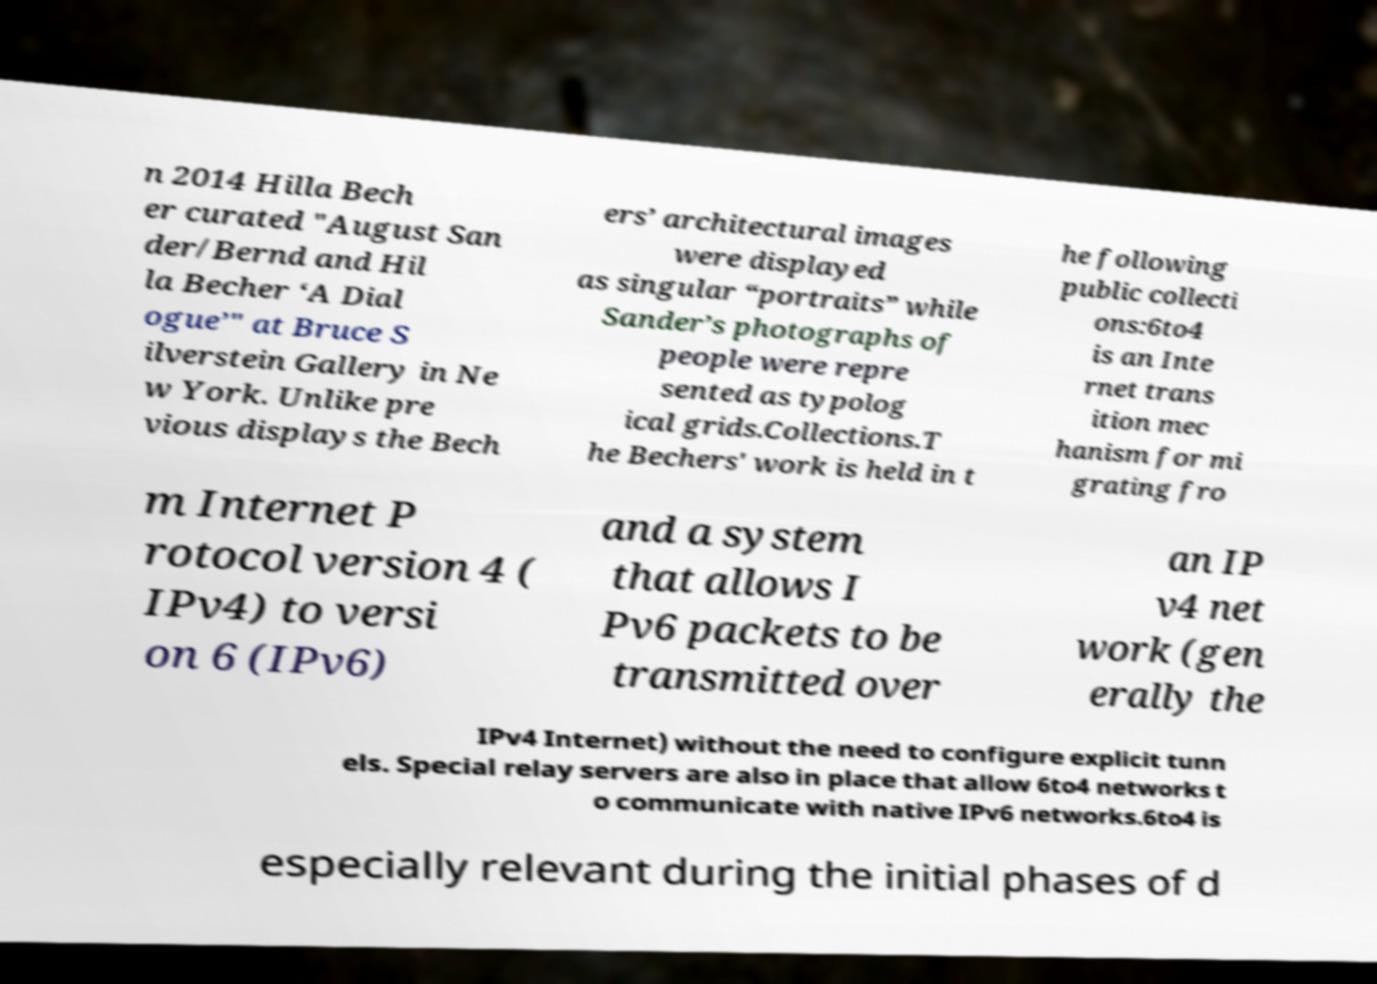Can you read and provide the text displayed in the image?This photo seems to have some interesting text. Can you extract and type it out for me? n 2014 Hilla Bech er curated "August San der/Bernd and Hil la Becher ‘A Dial ogue’" at Bruce S ilverstein Gallery in Ne w York. Unlike pre vious displays the Bech ers’ architectural images were displayed as singular “portraits” while Sander’s photographs of people were repre sented as typolog ical grids.Collections.T he Bechers' work is held in t he following public collecti ons:6to4 is an Inte rnet trans ition mec hanism for mi grating fro m Internet P rotocol version 4 ( IPv4) to versi on 6 (IPv6) and a system that allows I Pv6 packets to be transmitted over an IP v4 net work (gen erally the IPv4 Internet) without the need to configure explicit tunn els. Special relay servers are also in place that allow 6to4 networks t o communicate with native IPv6 networks.6to4 is especially relevant during the initial phases of d 